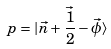Convert formula to latex. <formula><loc_0><loc_0><loc_500><loc_500>p = | \vec { n } + \vec { \frac { 1 } { 2 } } - \vec { \phi } \rangle</formula> 